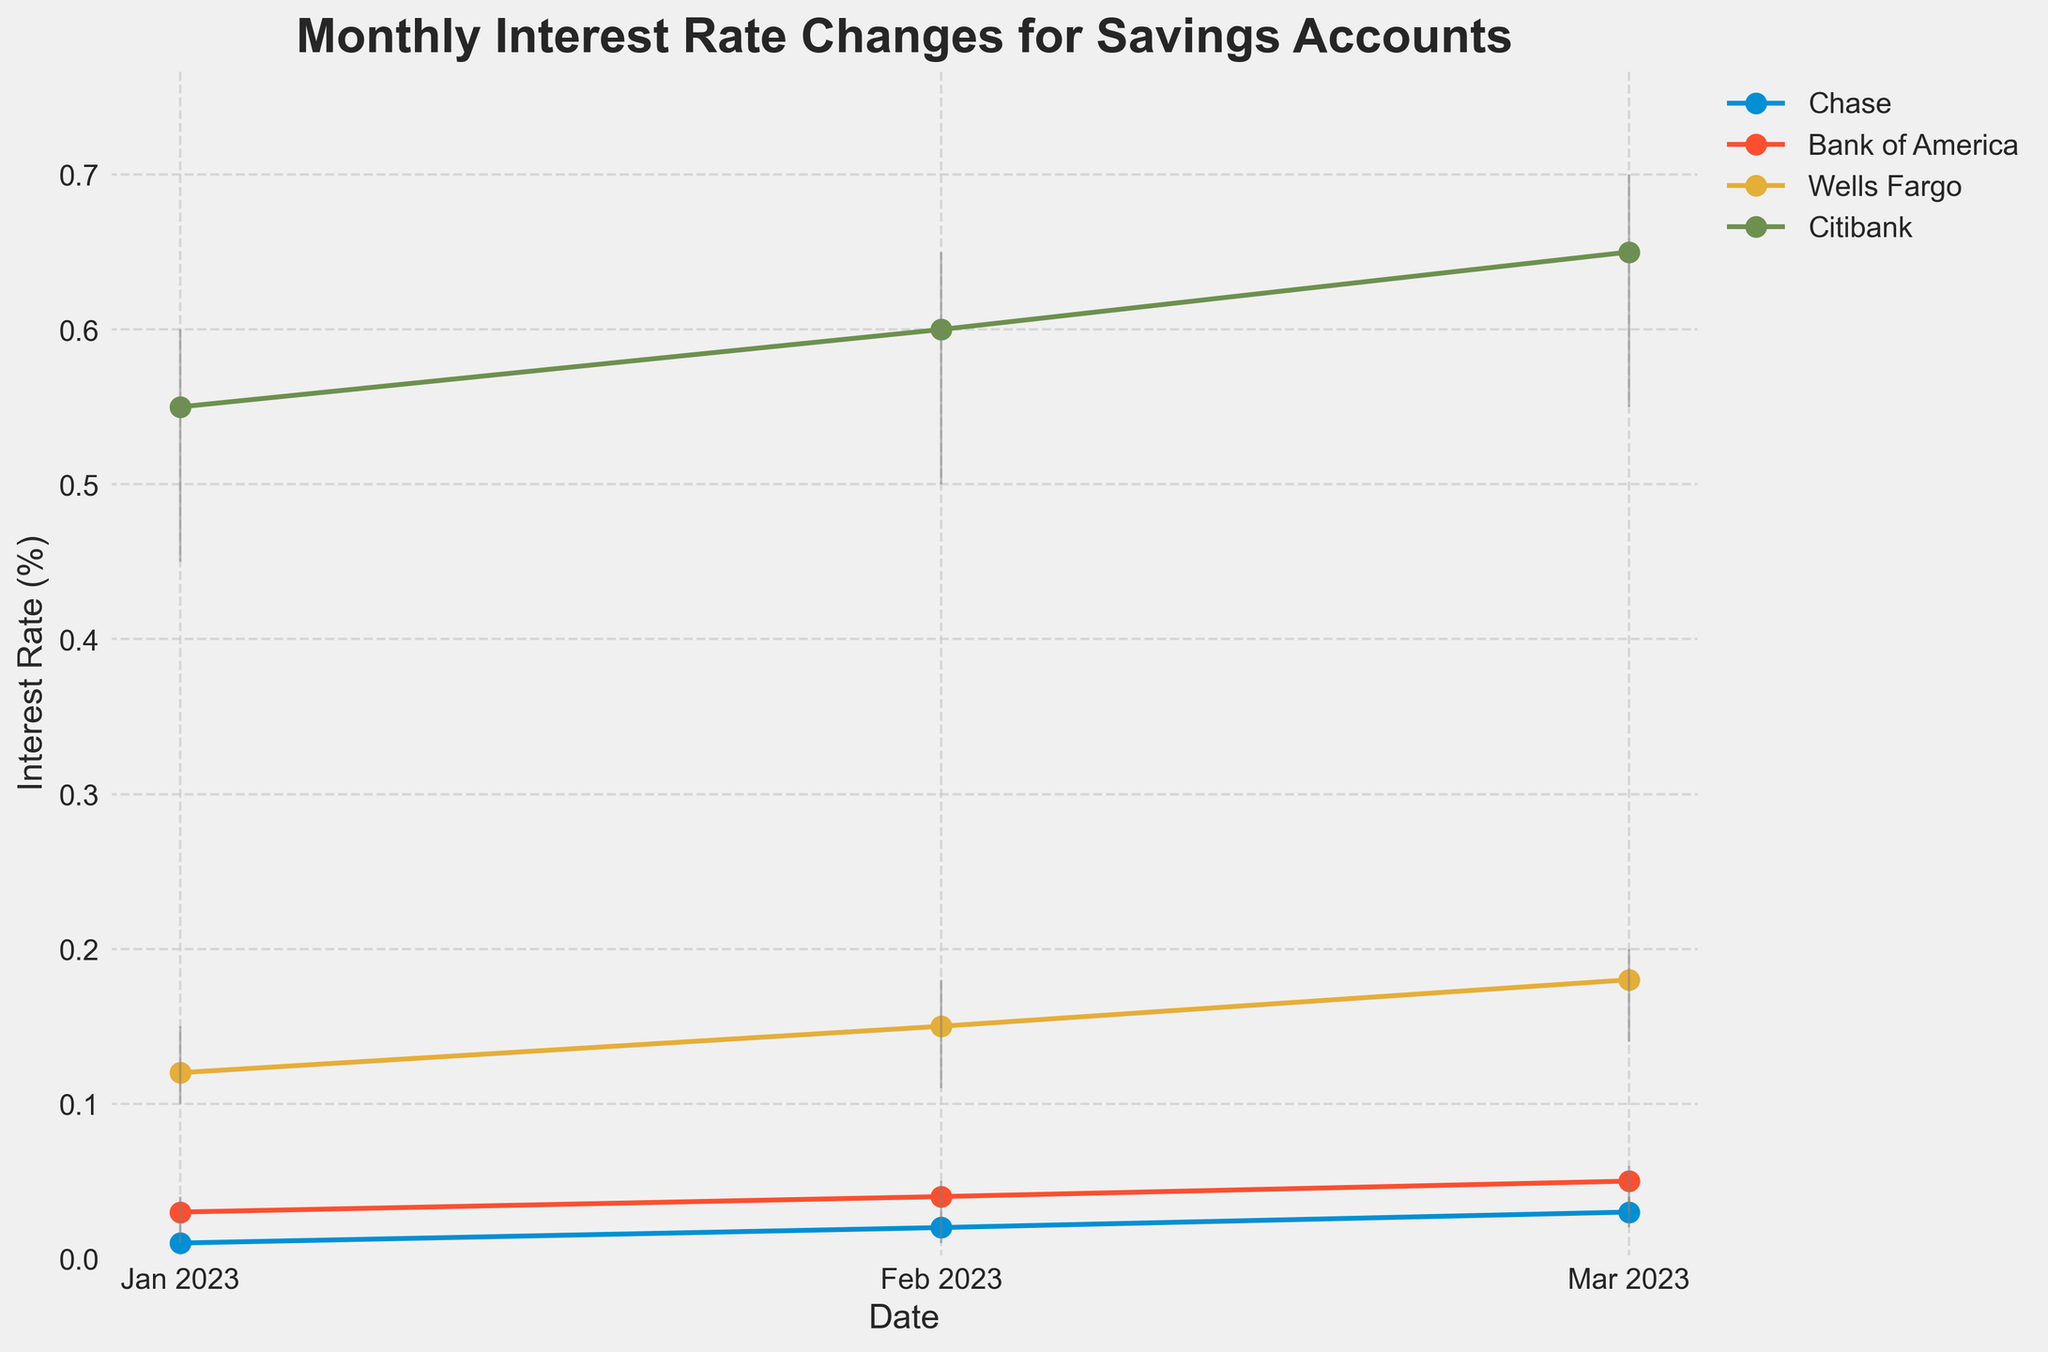What's the title of the figure? The title of the figure is typically found at the top of the chart and it summarizes what the chart represents. In this case, it is written in bold text.
Answer: Monthly Interest Rate Changes for Savings Accounts Which bank has the highest interest rate in March 2023? In March 2023, the interest rates for each bank can be seen where the Close price is marked on the chart. The highest close rate is from Citibank.
Answer: Citibank What is the general trend of interest rates for Chase Savings accounts from January to March 2023? Chase Savings accounts show interest rates starting from 0.01% in January, increasing to 0.02% in February, and then to 0.03% in March.
Answer: Increasing Which bank's account type shows the most fluctuation in interest rates? Fluctuation is measured by the range between the High and Low values. Citibank's High-Yield Savings account shows the widest range in each month.
Answer: Citibank's High-Yield Savings How does Bank of America's Money Market account compare from January to March 2023? In January, the interest rate closed at 0.03%. It increased to 0.04% in February, and then to 0.05% in March.
Answer: Increasing What is the percentage increase in interest rates for Wells Fargo's CD account from January to February 2023? From January, the Close rate was 0.12%, it increased to 0.15% in February. The increase is calculated as ((0.15 - 0.12) / 0.12) * 100.
Answer: 25% Which account type had the highest observed High rate in February 2023 and what was it? February's highest observed High rate among all account types can be found by looking at the tallest vertical line in February. It is Citibank’s High-Yield Savings at 0.65%.
Answer: Citibank’s High-Yield Savings, 0.65% How do the High and Low rates for Bank of America's Money Market account in March 2023 compare? In March 2023, the High rate is 0.06% and the Low rate is 0.03%. The difference is calculated as (0.06 - 0.03).
Answer: 0.03% Is there any month where Chase's Savings account experienced no change in the Close rate? By observing the Close rates over the months, January has no change as both Open and Close rates are 0.01%.
Answer: January What is the average interest rate for Citibank's High-Yield Savings account over the three months? The Close rates for January, February, and March are 0.55%, 0.60%, and 0.65% respectively. The average is calculated as (0.55 + 0.60 + 0.65) / 3.
Answer: 0.60% 